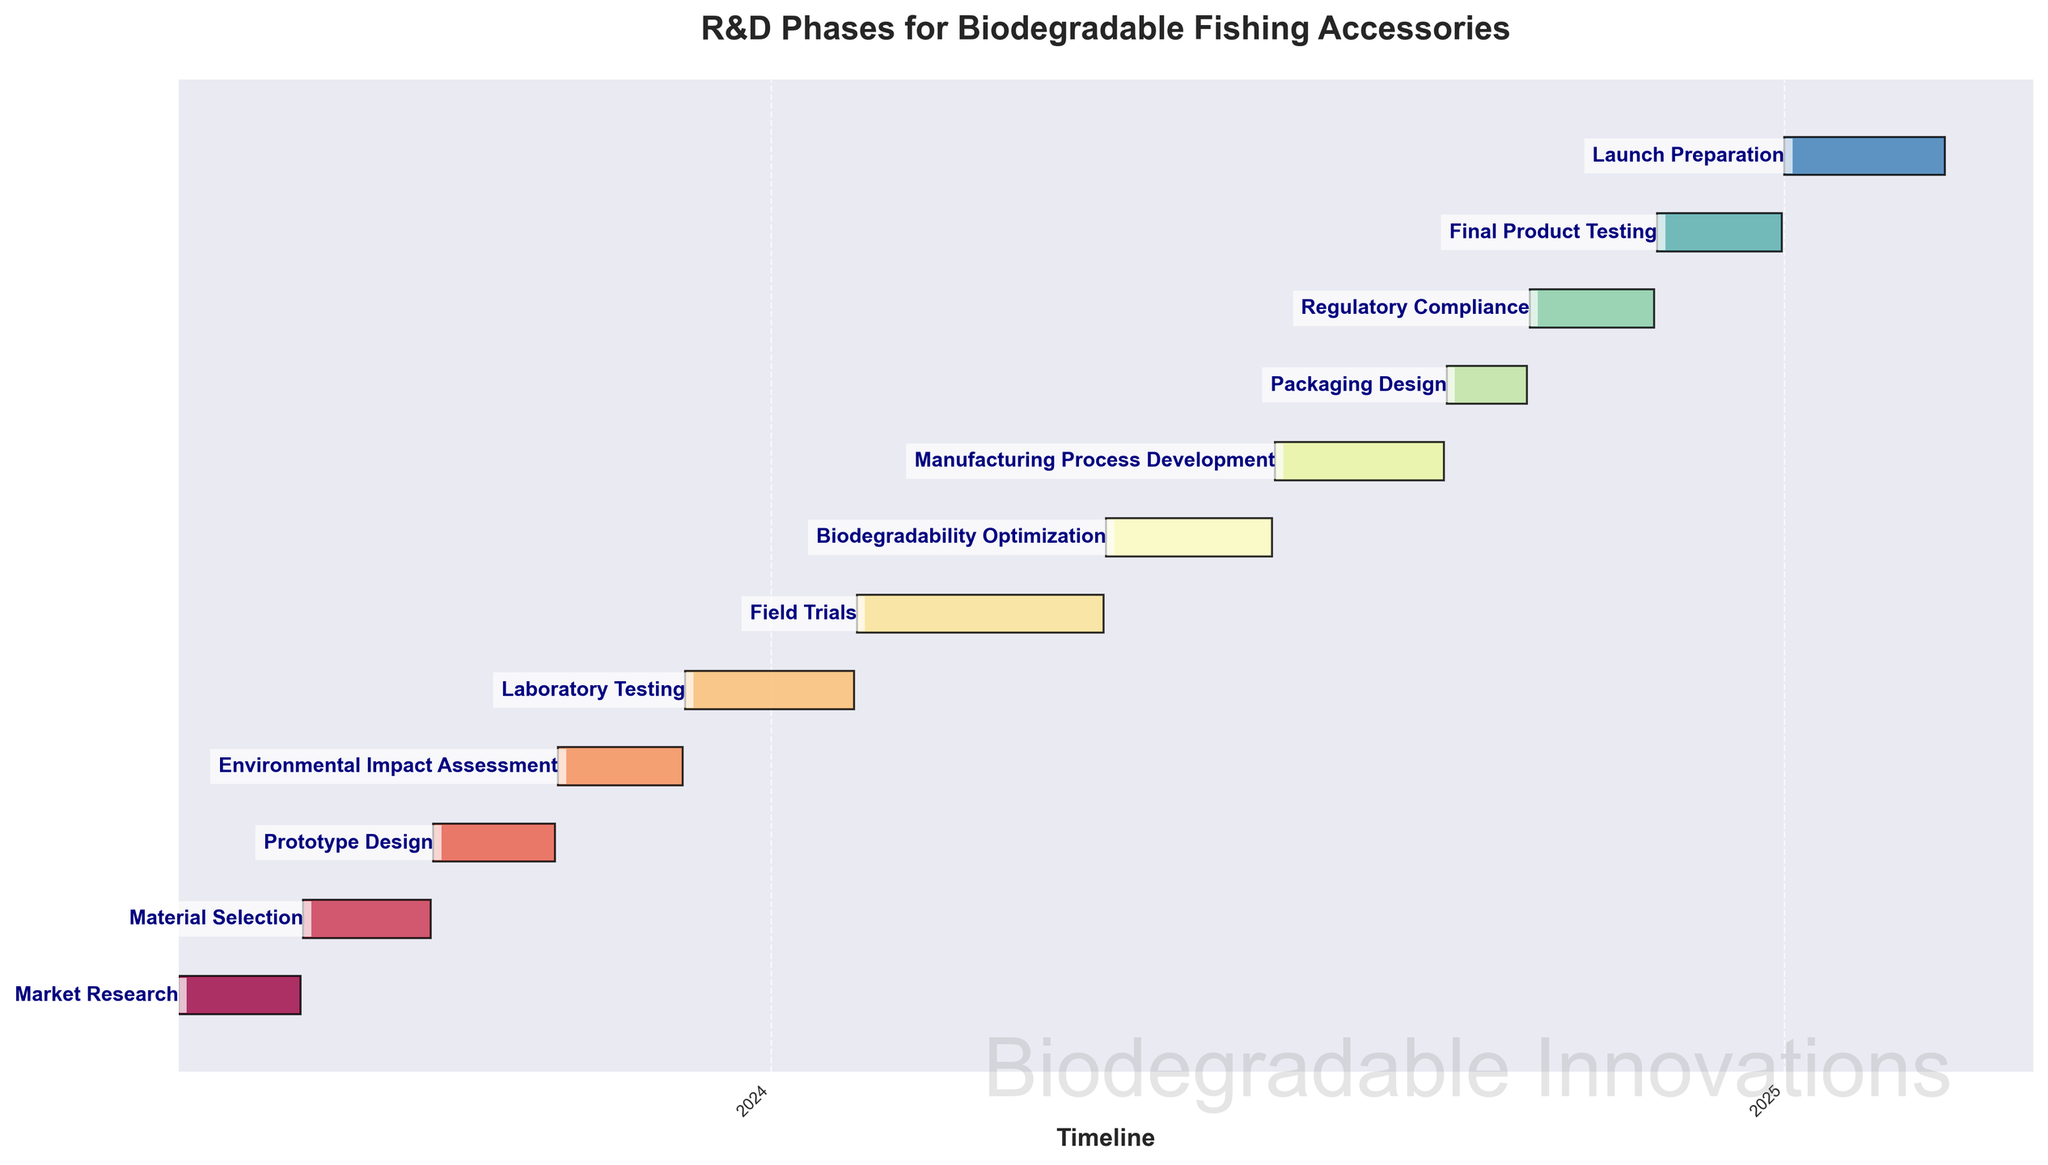Which task starts first? By looking at the Gantt Chart, the task that starts first would be at the topmost position. The starting point from the left indicates the start date. The earliest start date is June 1, 2023.
Answer: Market Research Which task ends last? To find the task that ends last, look for the bar that extends furthest to the right. The latest end date on the x-axis is February 28, 2025.
Answer: Launch Preparation What is the total number of tasks? By counting the number of horizontal bars on the Gantt Chart, we can determine the total number of tasks. Each bar represents a different task.
Answer: 12 Which task has the longest duration? To determine the task with the longest duration, you check the length of each bar. The bar stretching from February 1, 2024, to April 30, 2024, is the longest, covering 90 days.
Answer: Field Trials Which two tasks have the closest start dates? Check the beginning point of each bar to find the closest start dates. "Material Selection" starts on July 16, 2023, and "Prototype Design" starts on September 1, 2023, which are quite close.
Answer: Material Selection and Prototype Design In which year does the 'Biodegradability Optimization' task start and end? Look for the 'Biodegradability Optimization' bar on the chart, check its position against the x-axis's timeline. It starts on May 1, 2024, and ends on June 30, 2024, all within 2024.
Answer: 2024 What is the duration of the 'Laboratory Testing' task? Find the 'Laboratory Testing' bar and note the start and end dates. Then calculate the number of days between December 1, 2023, and January 31, 2024.
Answer: 62 days Which phase comes immediately before 'Final Product Testing'? Trace the position of 'Final Product Testing' and look at the task bar just above it. The preceding bar represents 'Regulatory Compliance', which ends on November 15, 2024, just before 'Final Product Testing' starts on November 16, 2024.
Answer: Regulatory Compliance How long is the gap between the end of 'Environmental Impact Assessment' and the start of 'Laboratory Testing'? Note the end date of 'Environmental Impact Assessment' (November 30, 2023) and the start date of 'Laboratory Testing' (December 1, 2023). Calculate the gap: (December 1, 2023 - November 30, 2023) = 1 day.
Answer: 1 day Which phase overlaps with 'Packaging Design'? Identify the duration of 'Packaging Design' and look for bars that overlap this time frame. 'Packaging Design' runs from September 1, 2024, to September 30, 2024. 'Manufacturing Process Development' overlaps from July 1, 2024, to August 31, 2024, and also the start of 'Regulatory Compliance' on October 1, 2024.
Answer: None 